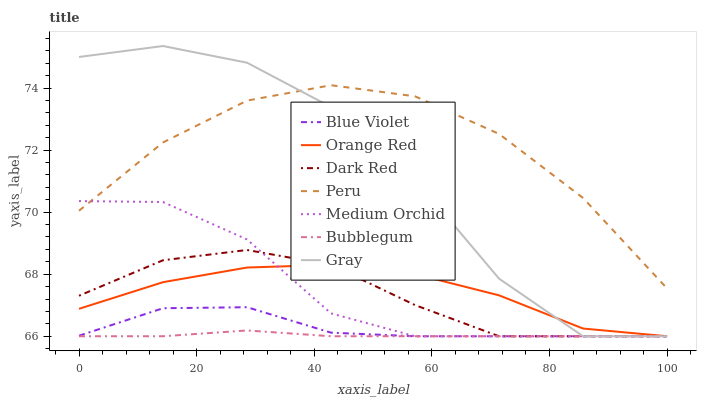Does Bubblegum have the minimum area under the curve?
Answer yes or no. Yes. Does Peru have the maximum area under the curve?
Answer yes or no. Yes. Does Dark Red have the minimum area under the curve?
Answer yes or no. No. Does Dark Red have the maximum area under the curve?
Answer yes or no. No. Is Bubblegum the smoothest?
Answer yes or no. Yes. Is Gray the roughest?
Answer yes or no. Yes. Is Dark Red the smoothest?
Answer yes or no. No. Is Dark Red the roughest?
Answer yes or no. No. Does Gray have the lowest value?
Answer yes or no. Yes. Does Peru have the lowest value?
Answer yes or no. No. Does Gray have the highest value?
Answer yes or no. Yes. Does Dark Red have the highest value?
Answer yes or no. No. Is Blue Violet less than Peru?
Answer yes or no. Yes. Is Peru greater than Blue Violet?
Answer yes or no. Yes. Does Bubblegum intersect Dark Red?
Answer yes or no. Yes. Is Bubblegum less than Dark Red?
Answer yes or no. No. Is Bubblegum greater than Dark Red?
Answer yes or no. No. Does Blue Violet intersect Peru?
Answer yes or no. No. 